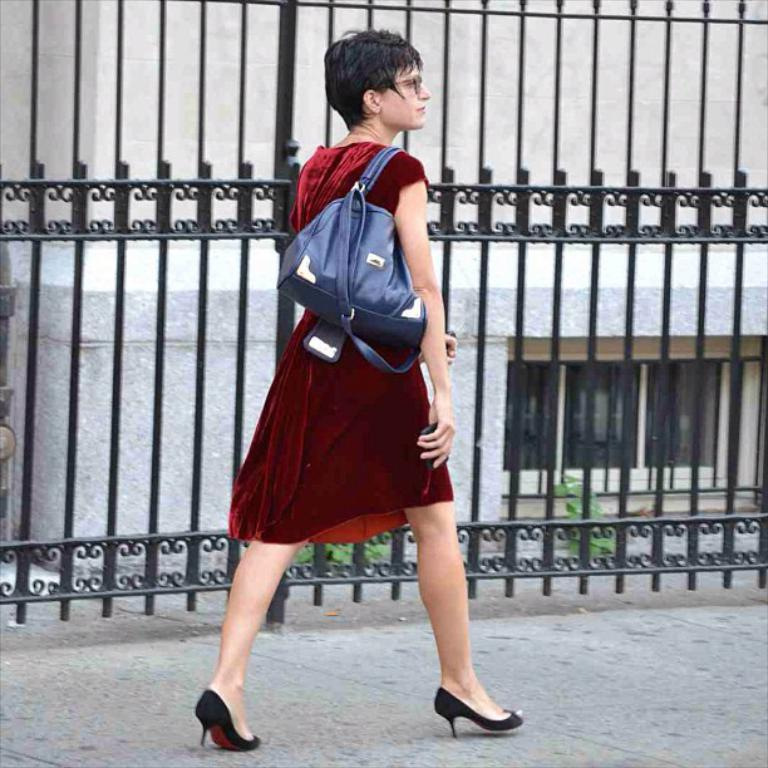Who is the main subject in the image? There is a lady in the center of the image. What is the lady doing in the image? The lady is walking. What is the lady carrying in the image? The lady is wearing a bag. What can be seen in the background of the image? There are grills and a building visible in the background of the image. What is the history of the branch depicted in the image? There is no branch present in the image, so it is not possible to discuss its history. 